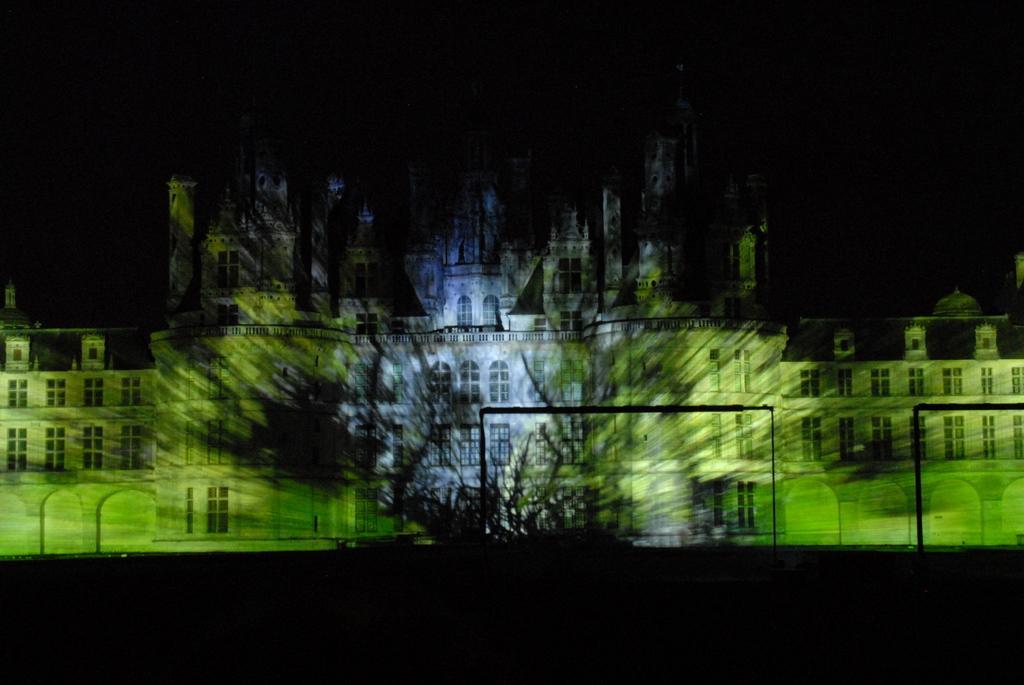Describe this image in one or two sentences. In this picture I can observe building. The background is completely dark. 